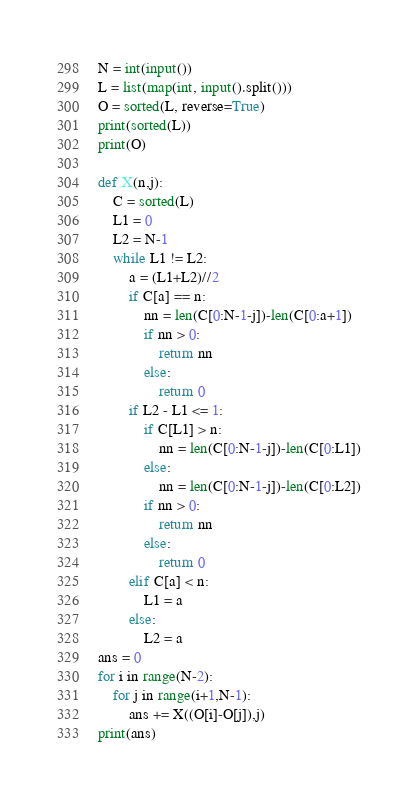Convert code to text. <code><loc_0><loc_0><loc_500><loc_500><_Python_>N = int(input())
L = list(map(int, input().split()))
O = sorted(L, reverse=True)
print(sorted(L))
print(O)

def X(n,j):
    C = sorted(L)
    L1 = 0
    L2 = N-1
    while L1 != L2:
        a = (L1+L2)//2
        if C[a] == n:
            nn = len(C[0:N-1-j])-len(C[0:a+1])
            if nn > 0:
                return nn
            else:
                return 0
        if L2 - L1 <= 1:
            if C[L1] > n:
                nn = len(C[0:N-1-j])-len(C[0:L1])
            else:
                nn = len(C[0:N-1-j])-len(C[0:L2])
            if nn > 0:
                return nn
            else:
                return 0
        elif C[a] < n:
            L1 = a
        else:
            L2 = a
ans = 0
for i in range(N-2):
    for j in range(i+1,N-1):
        ans += X((O[i]-O[j]),j)
print(ans)</code> 